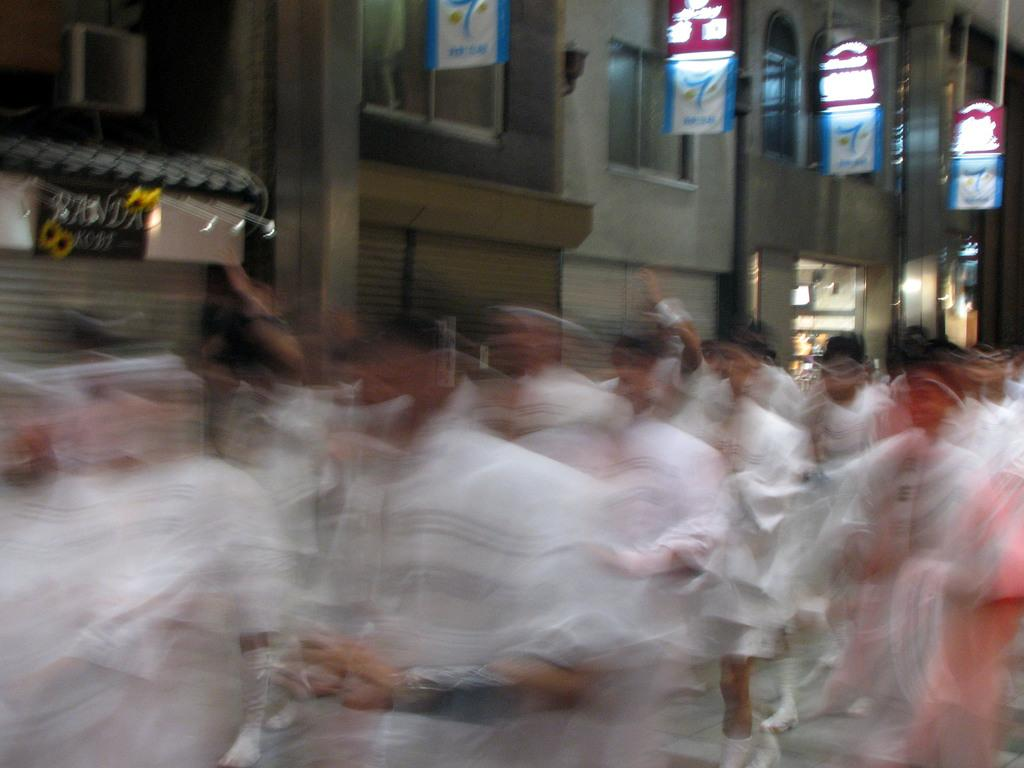What are the people in the image doing? The people in the image are walking. What structure can be seen in the image? There is a building in the image. What else is present in the image besides the people and the building? There are boards with text in the image. What type of quiver can be seen on the people's backs in the image? There is no quiver present on the people's backs in the image. How much money is being exchanged between the people in the image? There is no indication of money exchange in the image. 